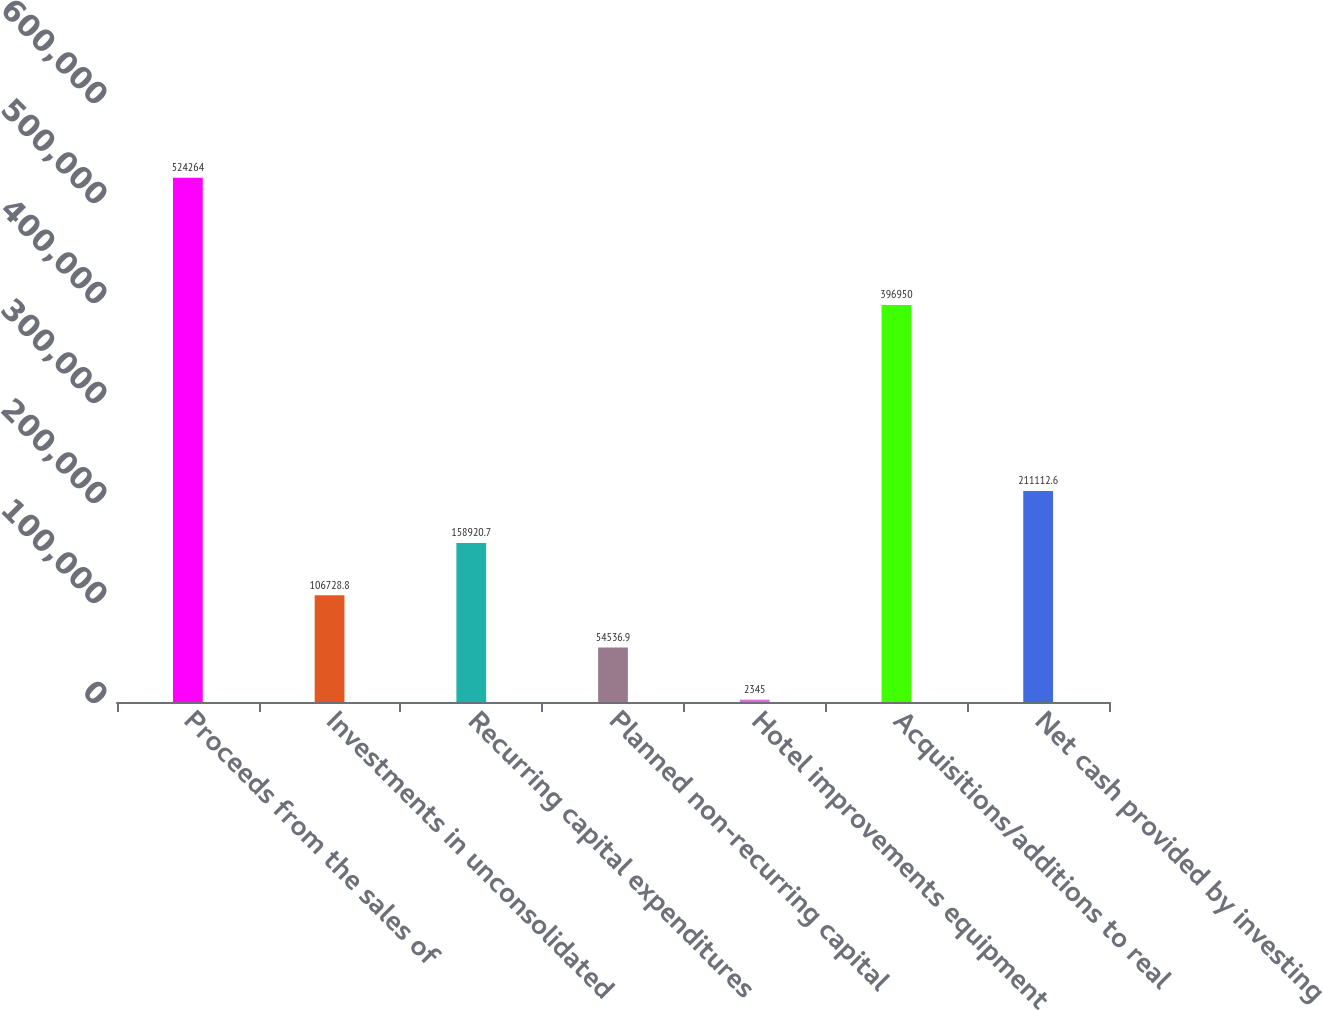Convert chart to OTSL. <chart><loc_0><loc_0><loc_500><loc_500><bar_chart><fcel>Proceeds from the sales of<fcel>Investments in unconsolidated<fcel>Recurring capital expenditures<fcel>Planned non-recurring capital<fcel>Hotel improvements equipment<fcel>Acquisitions/additions to real<fcel>Net cash provided by investing<nl><fcel>524264<fcel>106729<fcel>158921<fcel>54536.9<fcel>2345<fcel>396950<fcel>211113<nl></chart> 